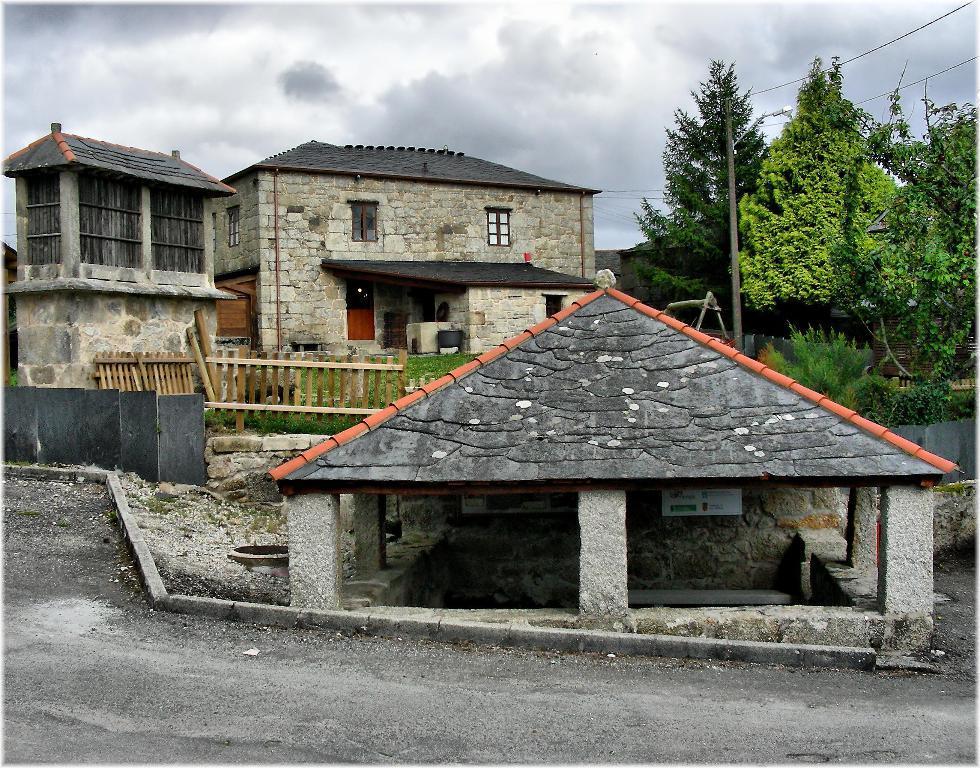Could you give a brief overview of what you see in this image? In this image we can see few houses. There are few trees in the image. There is an electrical pole and few cables connected to it. There is a board in the image. There is a street light at the right side of the image. We can see the cloudy sky in the image. There is a grassy land in the image. We can see the a road at the bottom of the image. There is a fence in the image. 